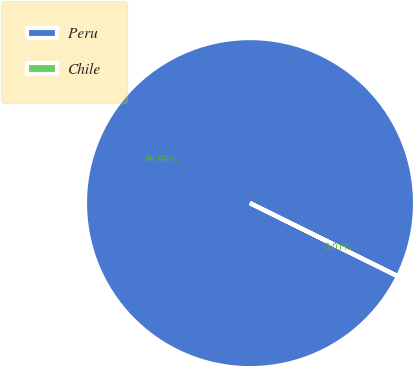Convert chart to OTSL. <chart><loc_0><loc_0><loc_500><loc_500><pie_chart><fcel>Peru<fcel>Chile<nl><fcel>99.99%<fcel>0.01%<nl></chart> 